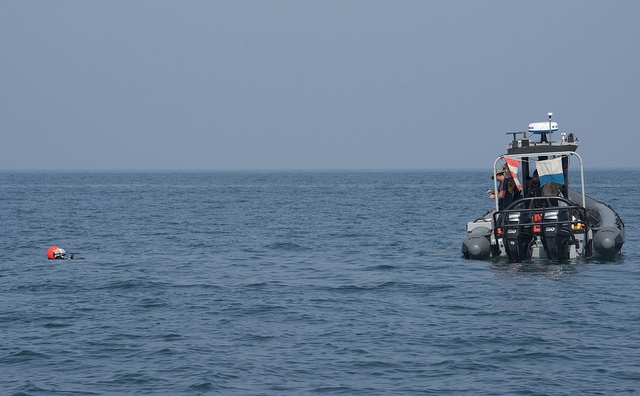Describe the objects in this image and their specific colors. I can see boat in darkgray, black, and gray tones, people in darkgray, black, gray, and brown tones, people in darkgray, black, blue, navy, and gray tones, and people in darkgray, gray, black, and brown tones in this image. 